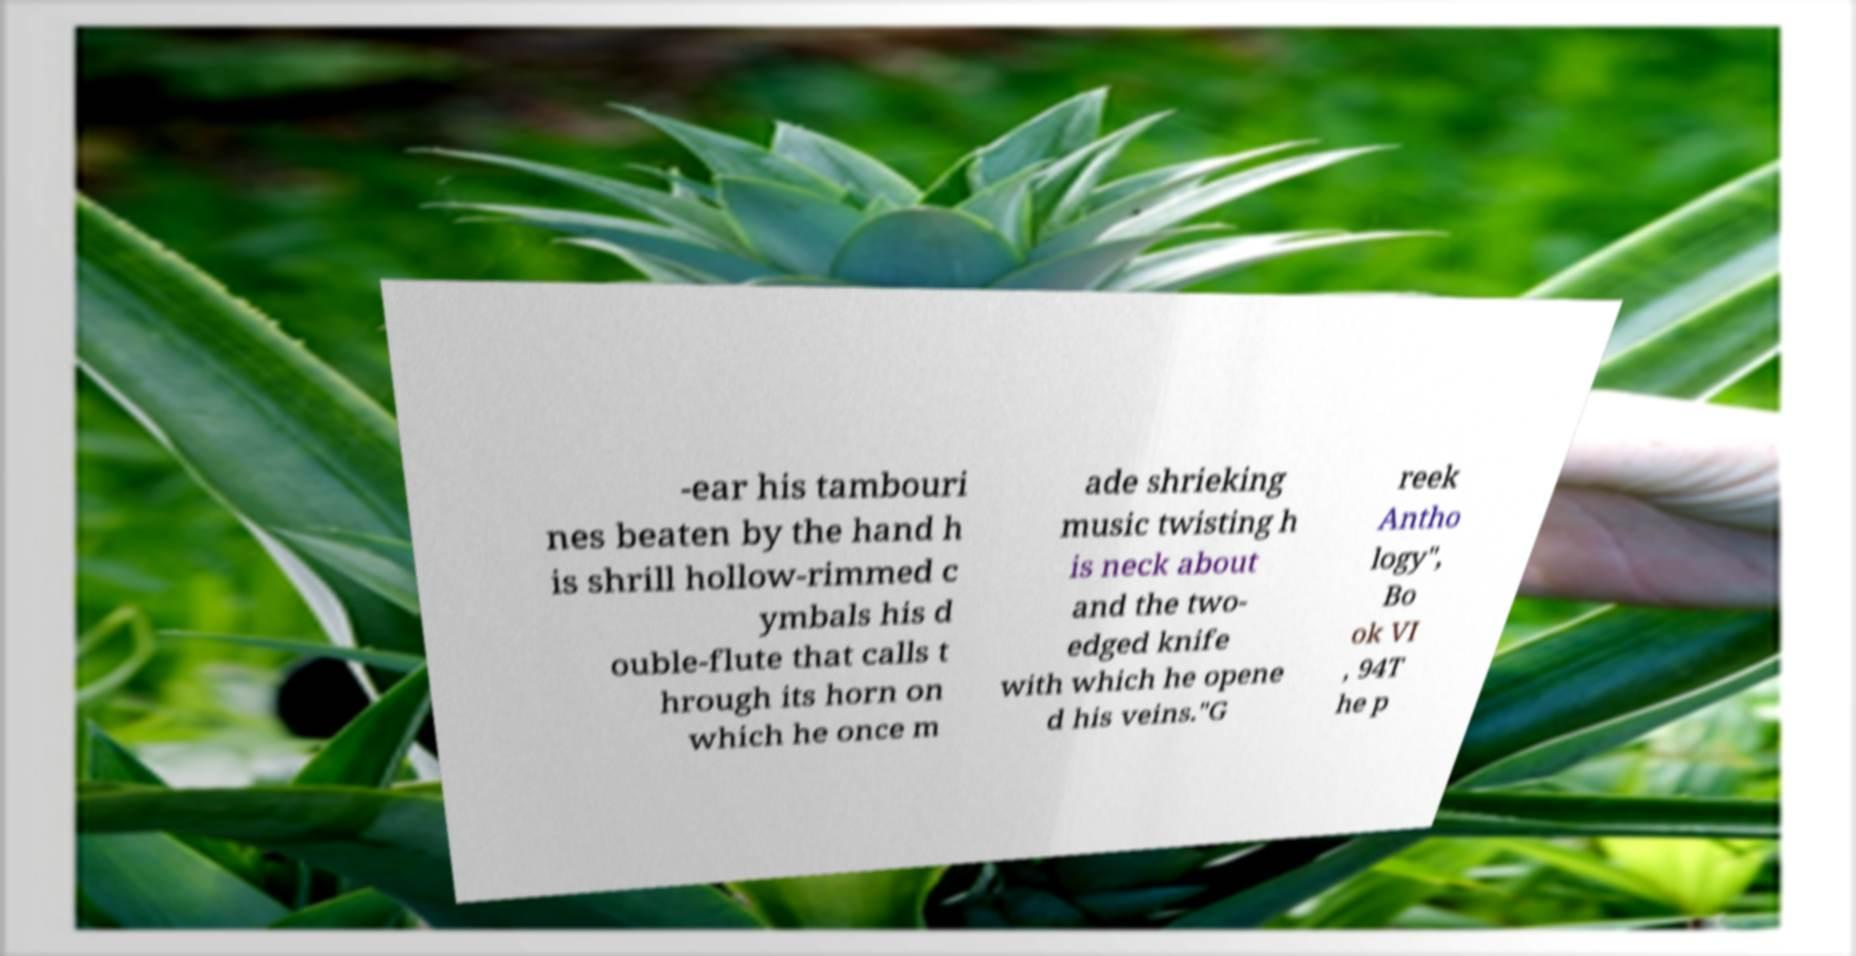For documentation purposes, I need the text within this image transcribed. Could you provide that? -ear his tambouri nes beaten by the hand h is shrill hollow-rimmed c ymbals his d ouble-flute that calls t hrough its horn on which he once m ade shrieking music twisting h is neck about and the two- edged knife with which he opene d his veins."G reek Antho logy", Bo ok VI , 94T he p 